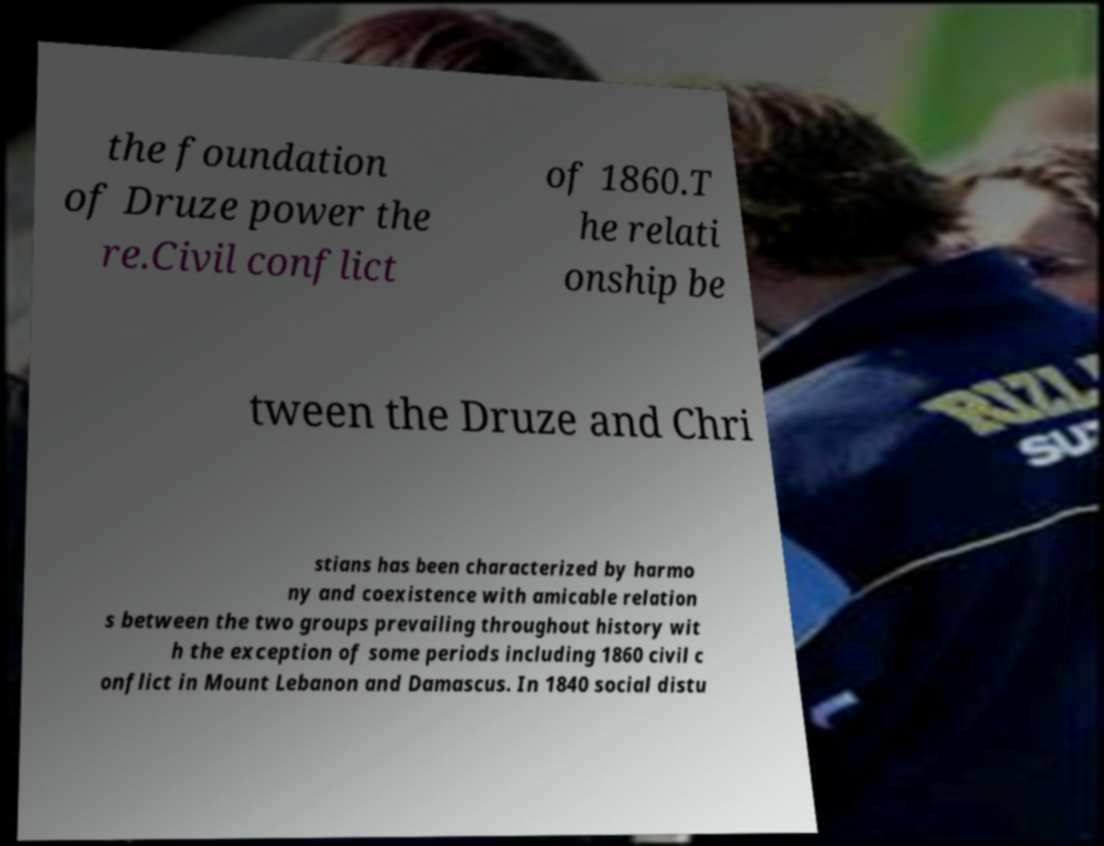I need the written content from this picture converted into text. Can you do that? the foundation of Druze power the re.Civil conflict of 1860.T he relati onship be tween the Druze and Chri stians has been characterized by harmo ny and coexistence with amicable relation s between the two groups prevailing throughout history wit h the exception of some periods including 1860 civil c onflict in Mount Lebanon and Damascus. In 1840 social distu 